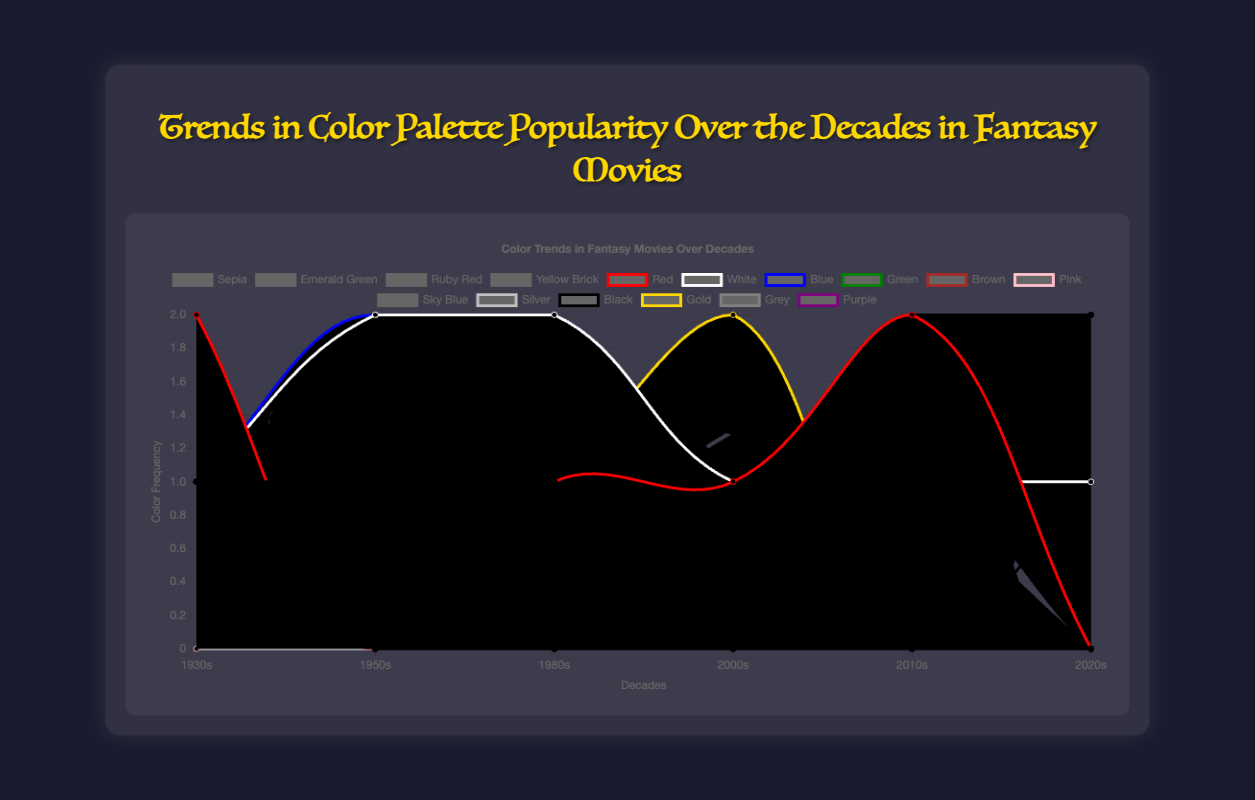Which decade had the highest frequency of the color "Emerald Green"? Look for the line representing "Emerald Green" and identify the decade where this line reaches its highest point.
Answer: 1930s How does the frequency of "Black" change from the 2000s to the 2020s? Compare the values of the "Black" line at the 2000s and 2020s. The frequency increases if the value is higher in the 2020s.
Answer: Increases What is the average frequency of the color "White" across all decades? Sum the frequencies of "White" across all decades and divide by the number of decades.
Answer: (3+3+3+2+2+2) / 6 = 15 / 6 = 2.5 Which color shows the most significant increase in frequency between the 1950s and 1980s? Check each color's frequency in the 1950s and 1980s, then find the color that has the largest difference.
Answer: White Is the frequency of "Green" higher or lower in the 1930s compared to the 2020s? Compare the height of the "Green" line in the 1930s to its height in the 2020s.
Answer: Higher Which two colors appear most frequently in the 2010s? Look at the line peaks in the 2010s and identify the two highest.
Answer: Black and Grey Does "Blue" maintain a consistent frequency across all decades? Observe the "Blue" line and check if it remains at a similar height across all decades.
Answer: No What is the total number of occurrences of "Red" in the 1930s, 2000s, and 2010s? Sum the frequency values of "Red" in these decades.
Answer: 1 (1930s) + 1 (2000s) + 2 (2010s) = 4 Which decade has the most diverse color palette, in terms of the number of different colors appearing? Count the number of different color lines that peak in each decade and identify the highest count.
Answer: 1930s How does the prevalence of "Gold" compare between the 1980s and the 2010s? Compare the peak points of the "Gold" line in the 1980s and the 2010s.
Answer: Higher in the 2010s 